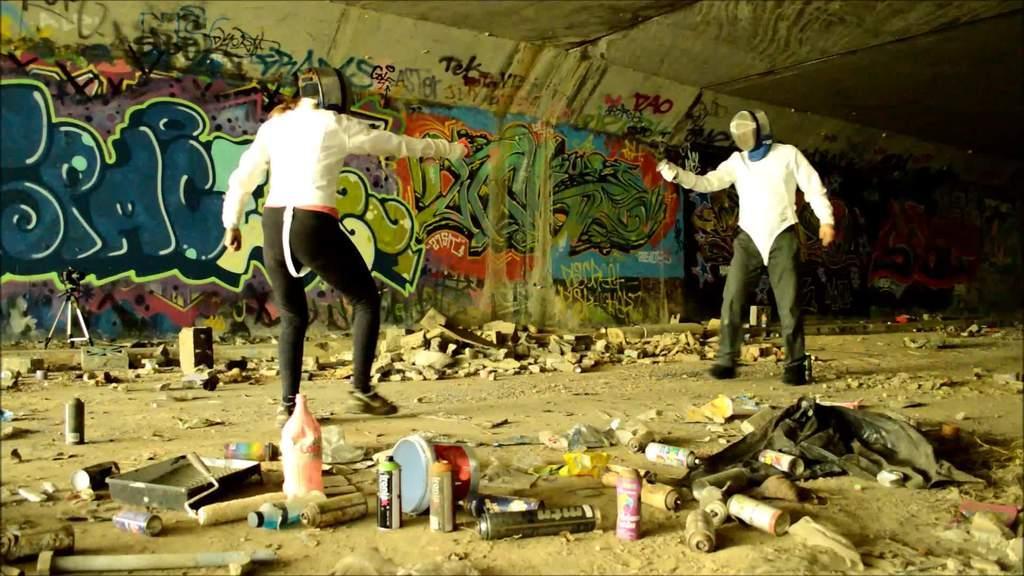Please provide a concise description of this image. This image is taken indoors. At the bottom of the image there is a ground. In the background there is a wall with many paintings and graffiti. At the top of the image there is a roof. In the middle of the image two persons are standing on the ground and they are holding spray bottles in their hands. There are many spray bottles, rollers and many things on the ground. 